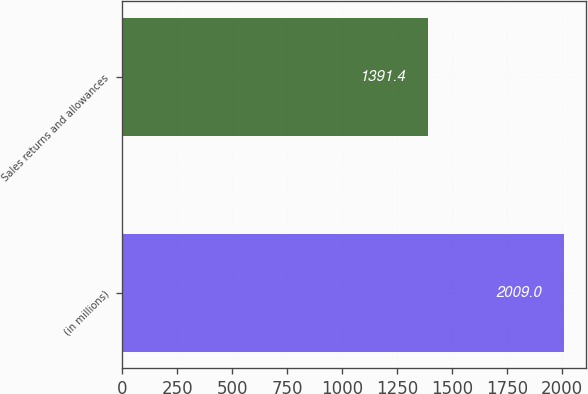<chart> <loc_0><loc_0><loc_500><loc_500><bar_chart><fcel>(in millions)<fcel>Sales returns and allowances<nl><fcel>2009<fcel>1391.4<nl></chart> 